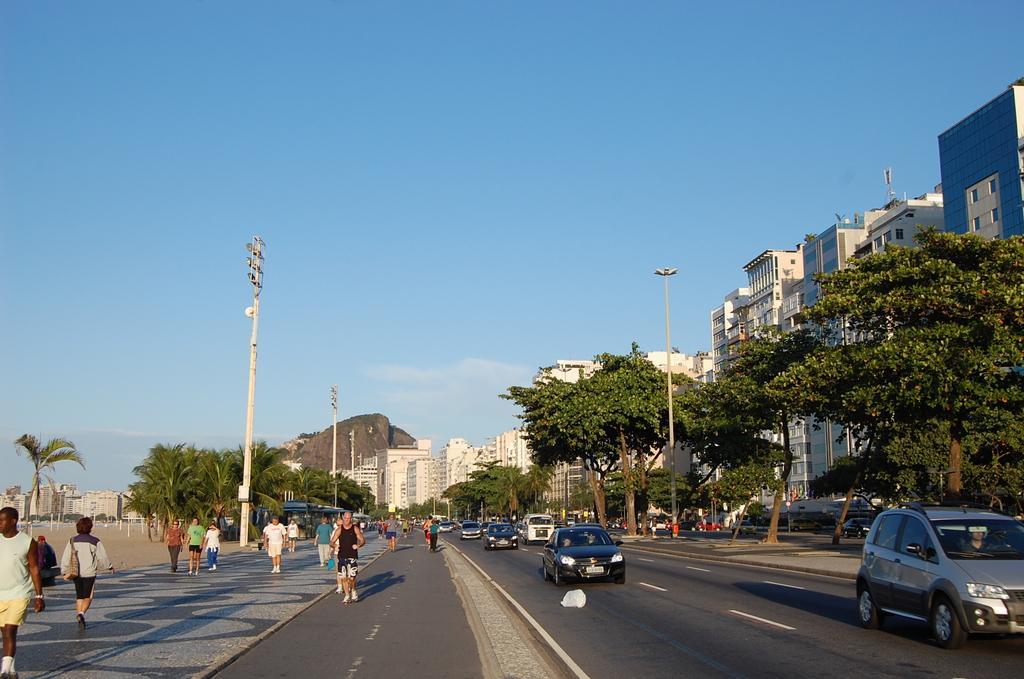Please provide a concise description of this image. On the left side of the image some persons are walking on the footpath. In the center of the image we can see a hill, poles are there. On the right side of the image we can see some trees, buildings, cars, tower are there. At the top of the image clouds are present in the sky. At the bottom of the image road is there. 